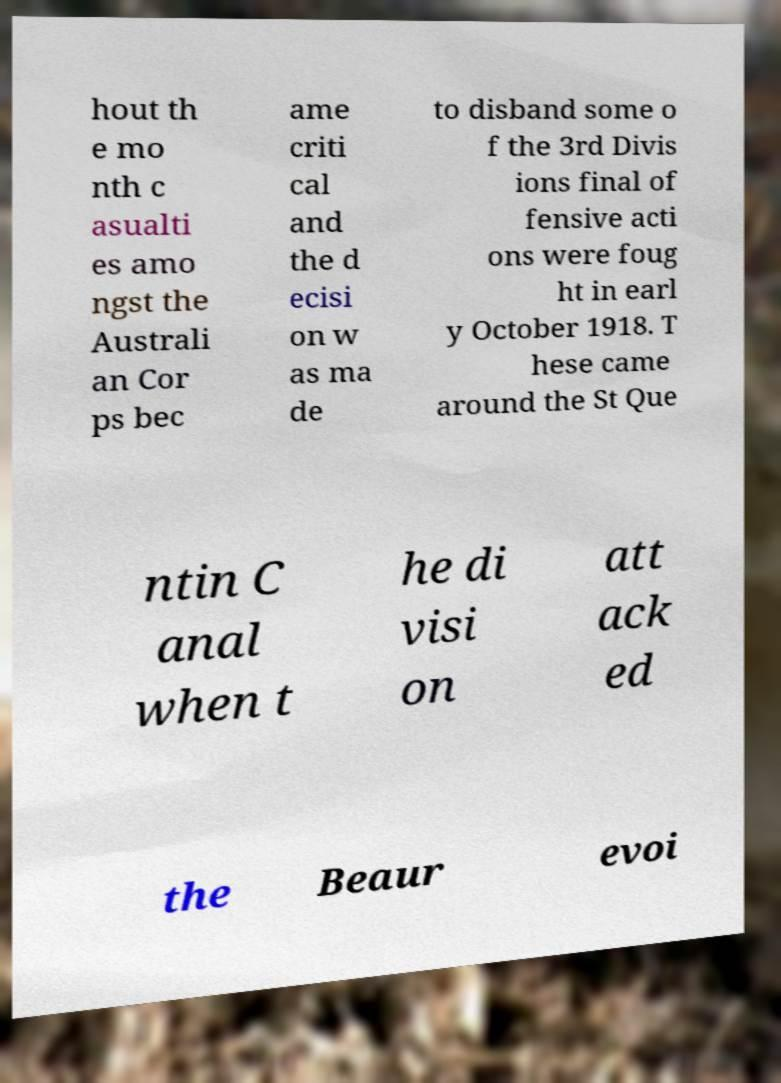Can you read and provide the text displayed in the image?This photo seems to have some interesting text. Can you extract and type it out for me? hout th e mo nth c asualti es amo ngst the Australi an Cor ps bec ame criti cal and the d ecisi on w as ma de to disband some o f the 3rd Divis ions final of fensive acti ons were foug ht in earl y October 1918. T hese came around the St Que ntin C anal when t he di visi on att ack ed the Beaur evoi 